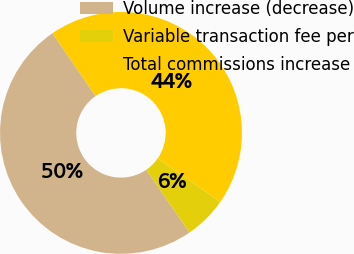Convert chart. <chart><loc_0><loc_0><loc_500><loc_500><pie_chart><fcel>Volume increase (decrease)<fcel>Variable transaction fee per<fcel>Total commissions increase<nl><fcel>50.0%<fcel>5.75%<fcel>44.25%<nl></chart> 